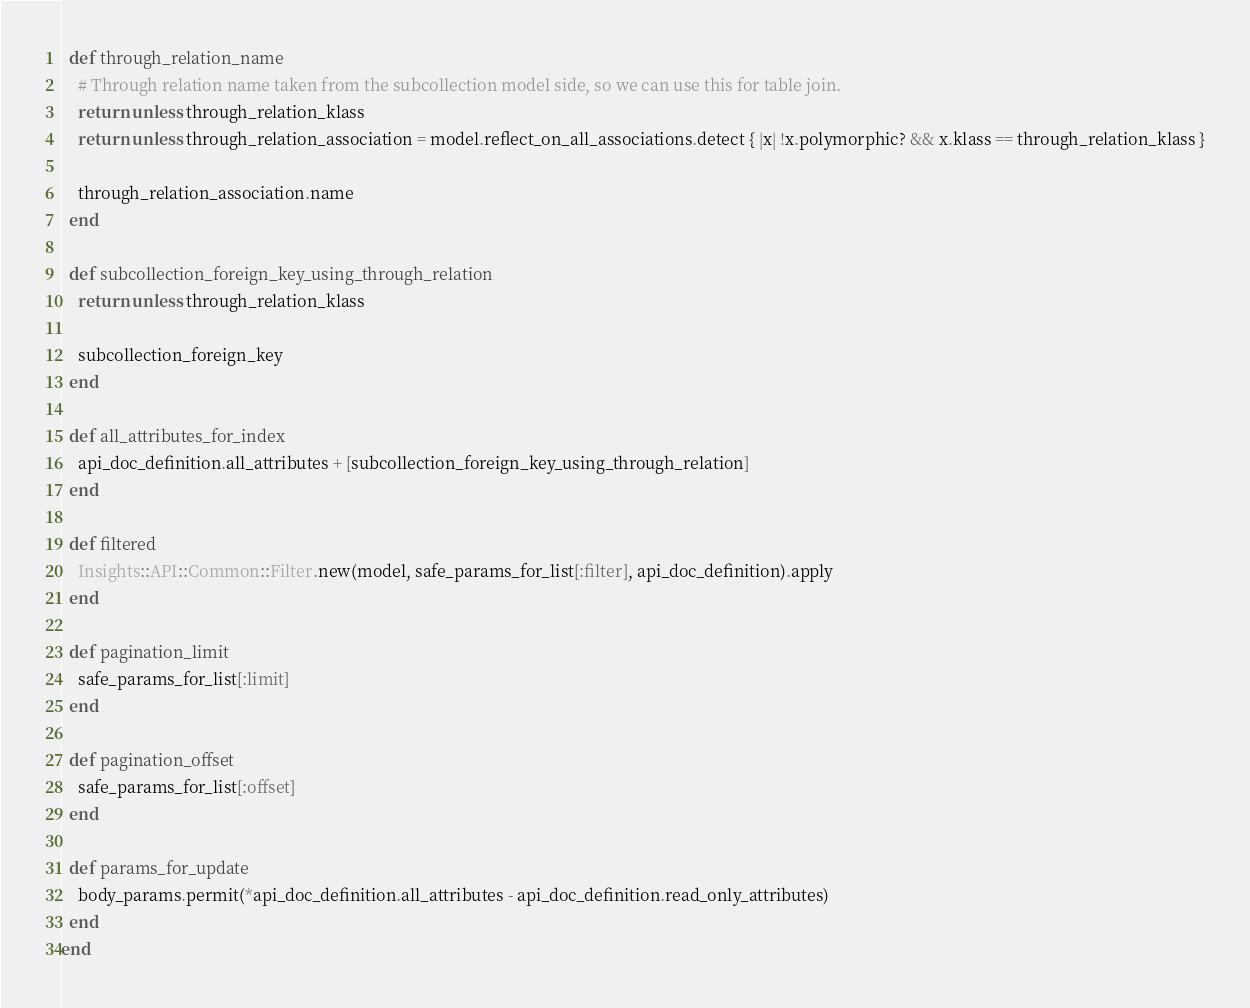<code> <loc_0><loc_0><loc_500><loc_500><_Ruby_>  def through_relation_name
    # Through relation name taken from the subcollection model side, so we can use this for table join.
    return unless through_relation_klass
    return unless through_relation_association = model.reflect_on_all_associations.detect { |x| !x.polymorphic? && x.klass == through_relation_klass }

    through_relation_association.name
  end

  def subcollection_foreign_key_using_through_relation
    return unless through_relation_klass

    subcollection_foreign_key
  end

  def all_attributes_for_index
    api_doc_definition.all_attributes + [subcollection_foreign_key_using_through_relation]
  end

  def filtered
    Insights::API::Common::Filter.new(model, safe_params_for_list[:filter], api_doc_definition).apply
  end

  def pagination_limit
    safe_params_for_list[:limit]
  end

  def pagination_offset
    safe_params_for_list[:offset]
  end

  def params_for_update
    body_params.permit(*api_doc_definition.all_attributes - api_doc_definition.read_only_attributes)
  end
end
</code> 